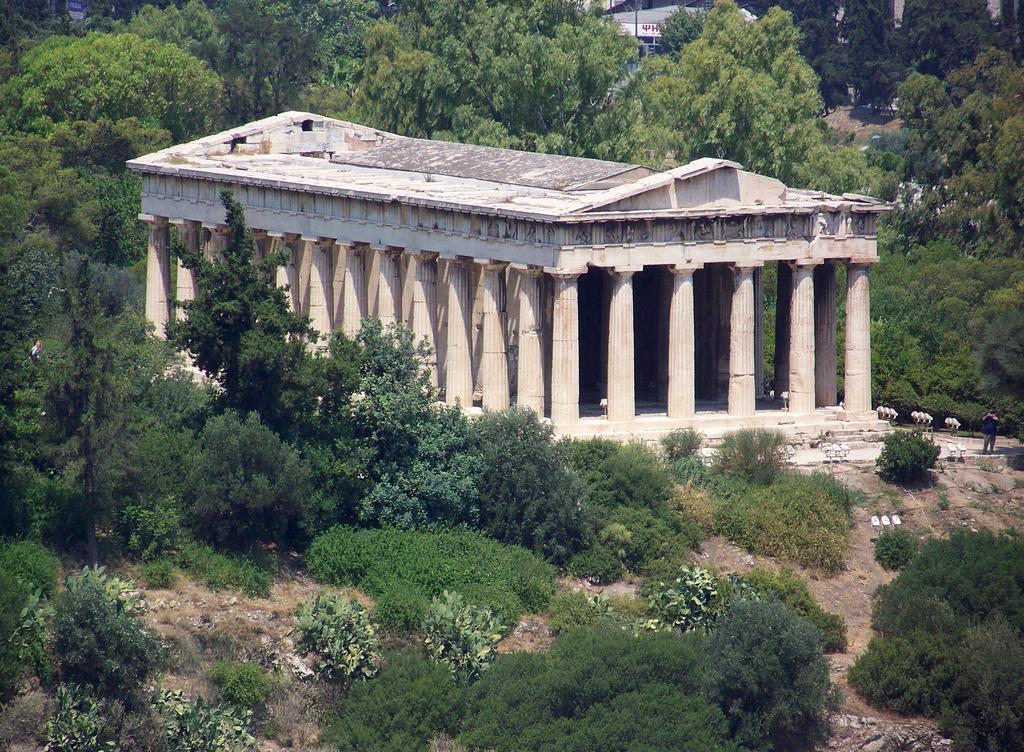How would you summarize this image in a sentence or two? In this image we can see the building with pillars. At the bottom of the image, plants are there on the land. There are trees at the top of the image. 